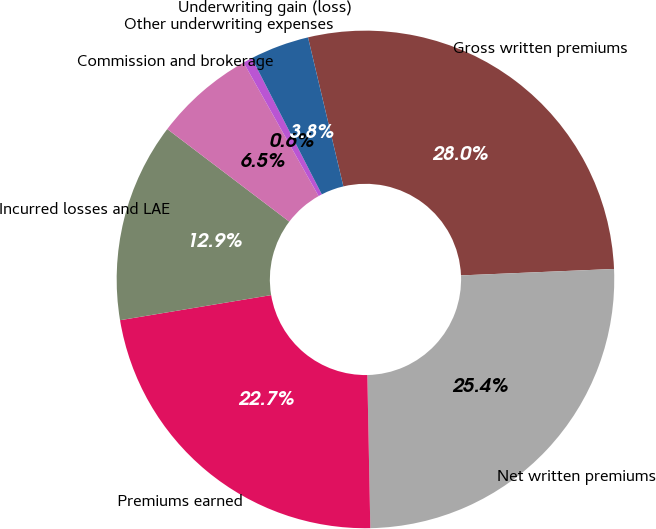Convert chart to OTSL. <chart><loc_0><loc_0><loc_500><loc_500><pie_chart><fcel>Gross written premiums<fcel>Net written premiums<fcel>Premiums earned<fcel>Incurred losses and LAE<fcel>Commission and brokerage<fcel>Other underwriting expenses<fcel>Underwriting gain (loss)<nl><fcel>28.04%<fcel>25.36%<fcel>22.69%<fcel>12.95%<fcel>6.52%<fcel>0.6%<fcel>3.84%<nl></chart> 